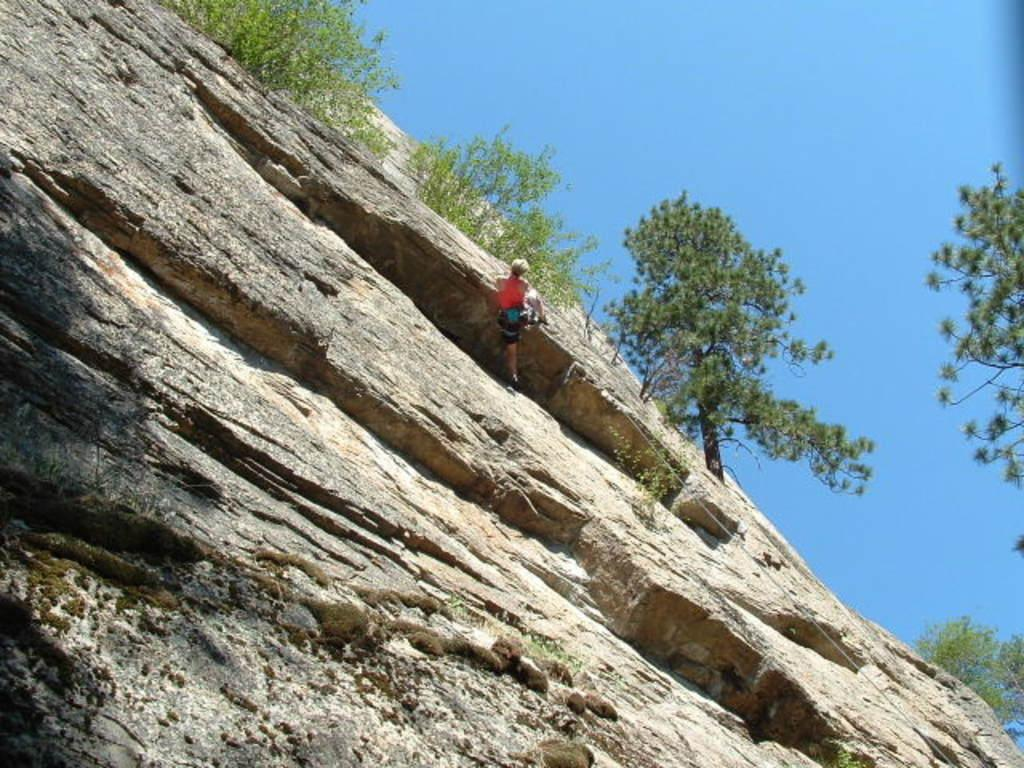What is the main activity of the person in the image? There is a person climbing a mountain in the image. What tool is being used by the person climbing the mountain? There is a rope in the image, which may be used by the person climbing the mountain. What type of natural environment can be seen in the image? There are trees visible in the image, indicating a forested area. What is visible above the trees and person in the image? The sky is visible in the image. How many kittens are playing with the clock in the image? There are no kittens or clocks present in the image; it features a person climbing a mountain with a rope and trees in the background. 